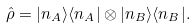Convert formula to latex. <formula><loc_0><loc_0><loc_500><loc_500>\hat { \rho } = | n _ { A } \rangle \langle n _ { A } | \otimes | n _ { B } \rangle \langle n _ { B } | .</formula> 